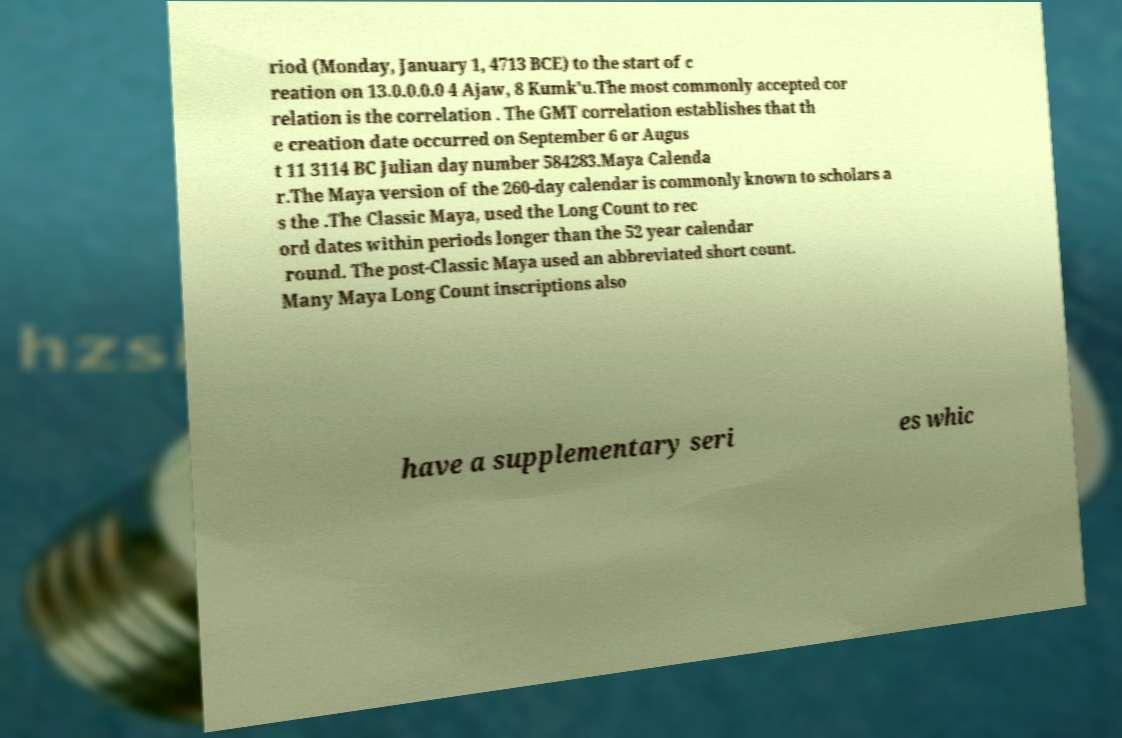Can you accurately transcribe the text from the provided image for me? riod (Monday, January 1, 4713 BCE) to the start of c reation on 13.0.0.0.0 4 Ajaw, 8 Kumk'u.The most commonly accepted cor relation is the correlation . The GMT correlation establishes that th e creation date occurred on September 6 or Augus t 11 3114 BC Julian day number 584283.Maya Calenda r.The Maya version of the 260-day calendar is commonly known to scholars a s the .The Classic Maya, used the Long Count to rec ord dates within periods longer than the 52 year calendar round. The post-Classic Maya used an abbreviated short count. Many Maya Long Count inscriptions also have a supplementary seri es whic 